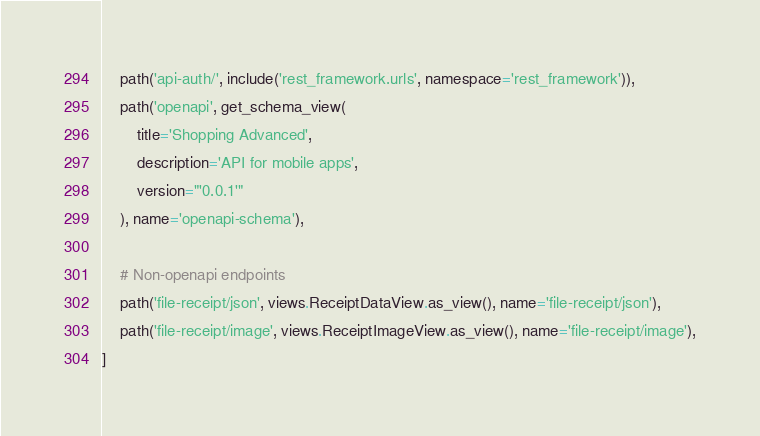<code> <loc_0><loc_0><loc_500><loc_500><_Python_>    path('api-auth/', include('rest_framework.urls', namespace='rest_framework')),
    path('openapi', get_schema_view(
        title='Shopping Advanced',
        description='API for mobile apps',
        version="'0.0.1'"
    ), name='openapi-schema'),

    # Non-openapi endpoints
    path('file-receipt/json', views.ReceiptDataView.as_view(), name='file-receipt/json'),
    path('file-receipt/image', views.ReceiptImageView.as_view(), name='file-receipt/image'),
]</code> 